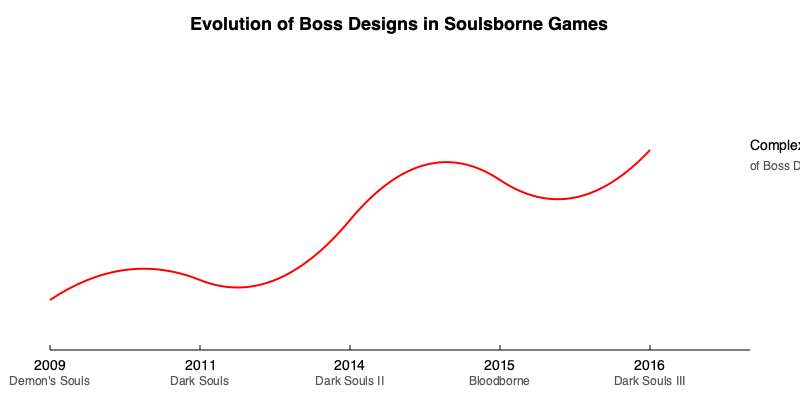Based on the timeline of Soulsborne games shown, which entry marked a significant shift in boss design complexity, introducing more aggressive and intricate patterns that would influence future titles? To answer this question, we need to analyze the evolution of boss designs in Soulsborne games as depicted in the timeline:

1. Demon's Souls (2009): This game established the foundation for boss fights in the series, but designs were relatively simpler compared to later entries.

2. Dark Souls (2011): Builds upon Demon's Souls, introducing more varied boss designs but still maintaining a similar level of complexity.

3. Dark Souls II (2014): Shows a slight increase in boss design complexity, but not a drastic change from its predecessors.

4. Bloodborne (2015): This is where we see a significant jump in the complexity curve. Bloodborne introduced faster-paced combat and more aggressive boss designs, marking a clear shift in the series' approach to boss fights.

5. Dark Souls III (2016): Continues the trend set by Bloodborne, incorporating more complex and aggressive boss designs into the Dark Souls formula.

The graph shows a notable increase in complexity between Dark Souls II and Bloodborne, indicating that Bloodborne was the game that introduced a significant shift in boss design complexity. This change influenced the design of bosses in subsequent games, particularly Dark Souls III.
Answer: Bloodborne (2015) 